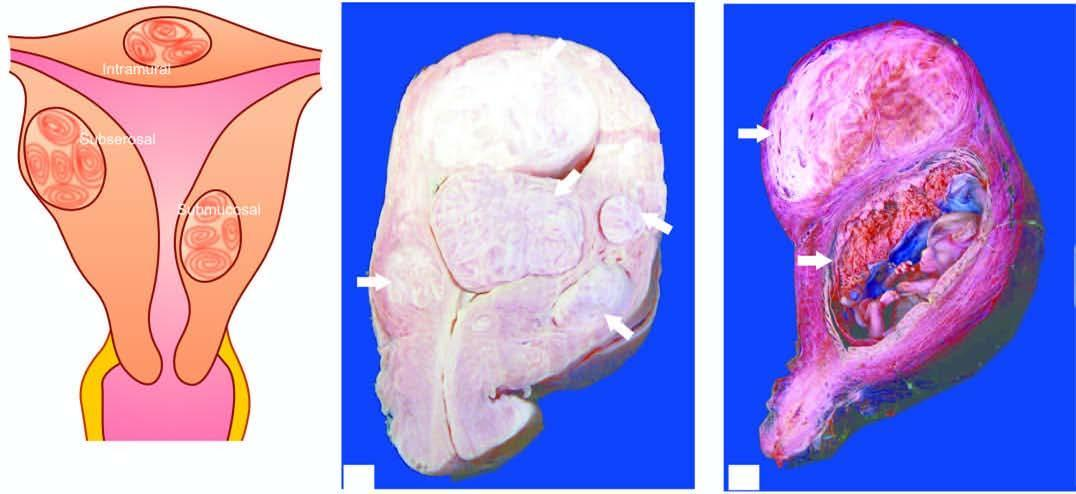does the opened up uterine cavity show an intrauterine gestation sac with placenta having grey-white whorled pattern?
Answer the question using a single word or phrase. Yes 